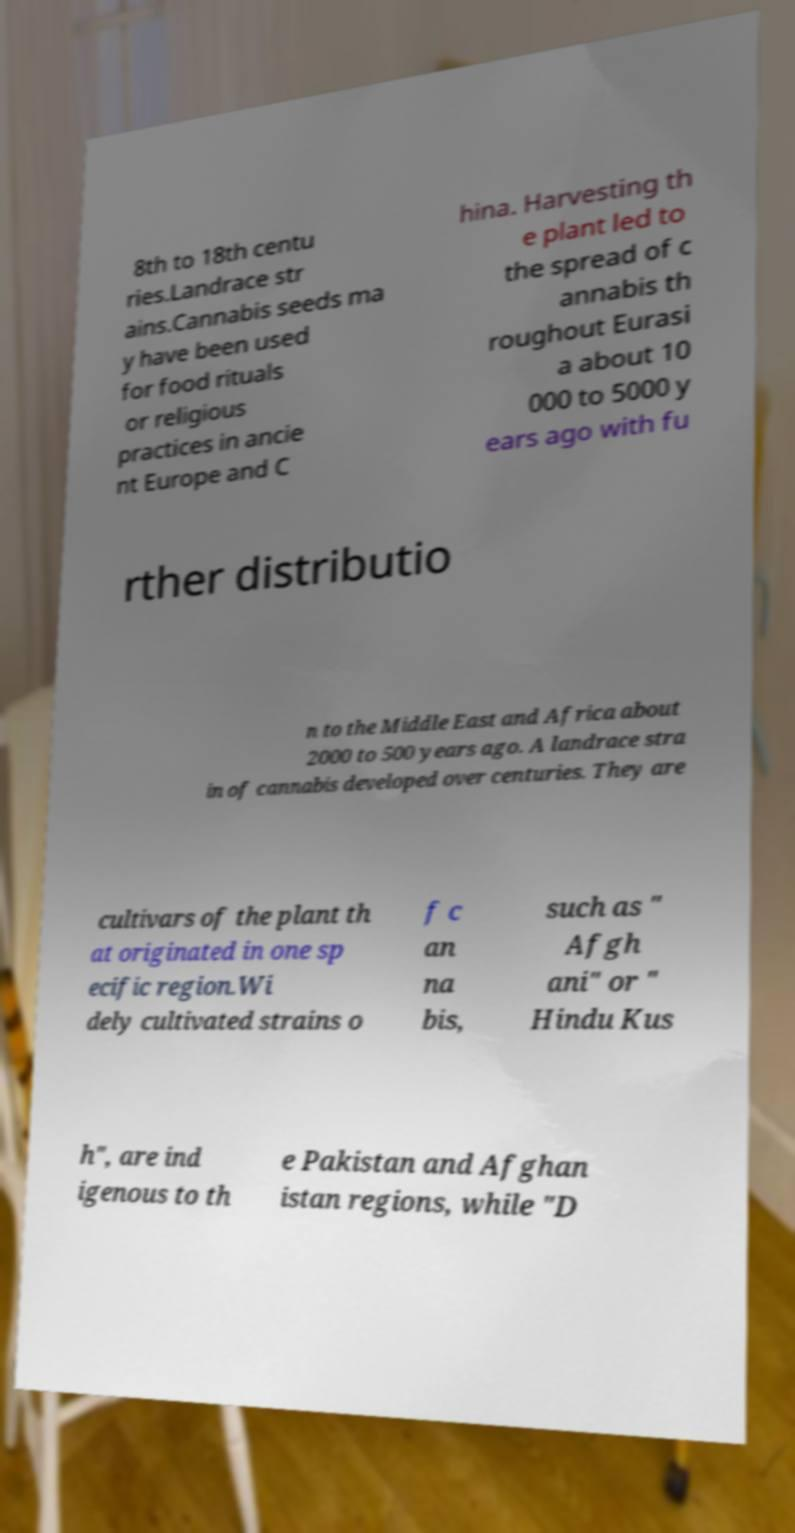What messages or text are displayed in this image? I need them in a readable, typed format. 8th to 18th centu ries.Landrace str ains.Cannabis seeds ma y have been used for food rituals or religious practices in ancie nt Europe and C hina. Harvesting th e plant led to the spread of c annabis th roughout Eurasi a about 10 000 to 5000 y ears ago with fu rther distributio n to the Middle East and Africa about 2000 to 500 years ago. A landrace stra in of cannabis developed over centuries. They are cultivars of the plant th at originated in one sp ecific region.Wi dely cultivated strains o f c an na bis, such as " Afgh ani" or " Hindu Kus h", are ind igenous to th e Pakistan and Afghan istan regions, while "D 